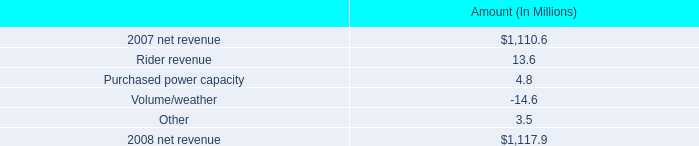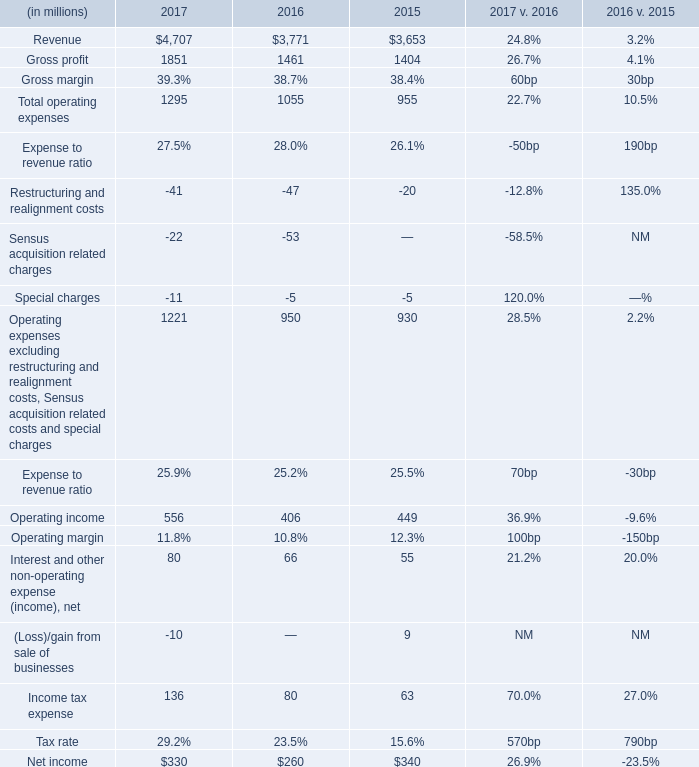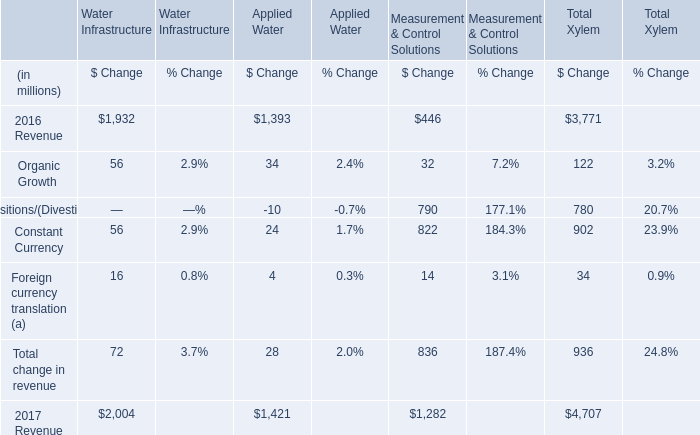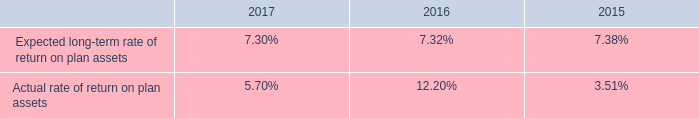what is the percent change in net revenue between 2007 and 2008? 
Computations: ((1110.6 - 1117.9) / 1117.9)
Answer: -0.00653. 